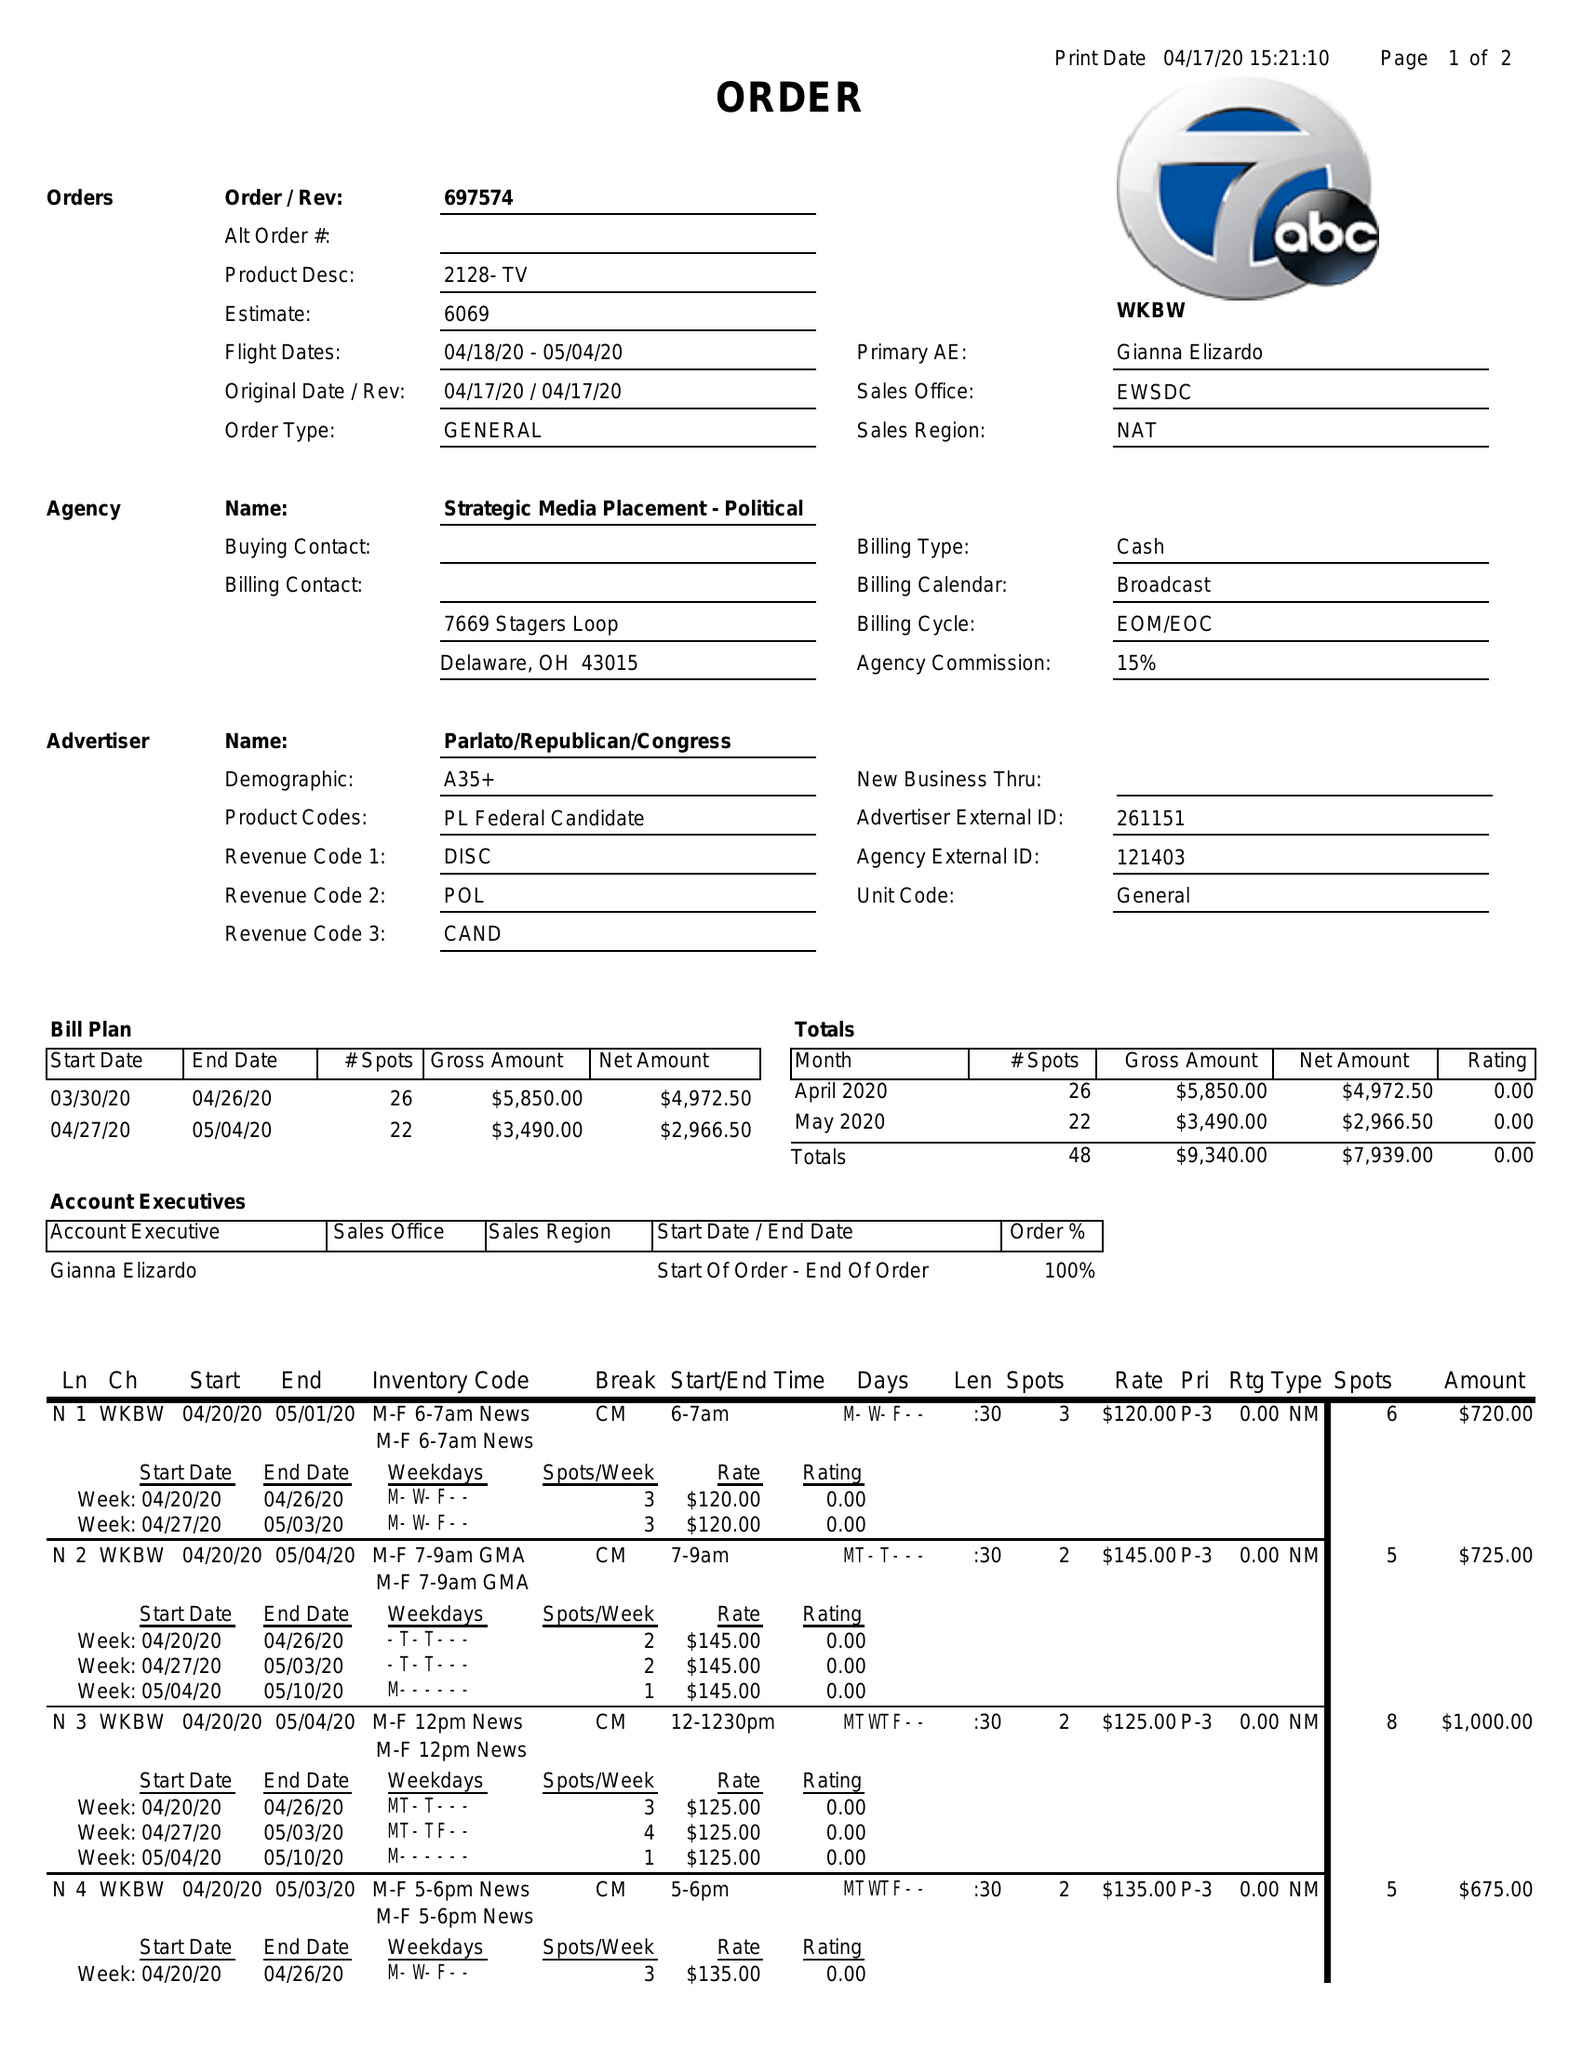What is the value for the gross_amount?
Answer the question using a single word or phrase. 9340.00 